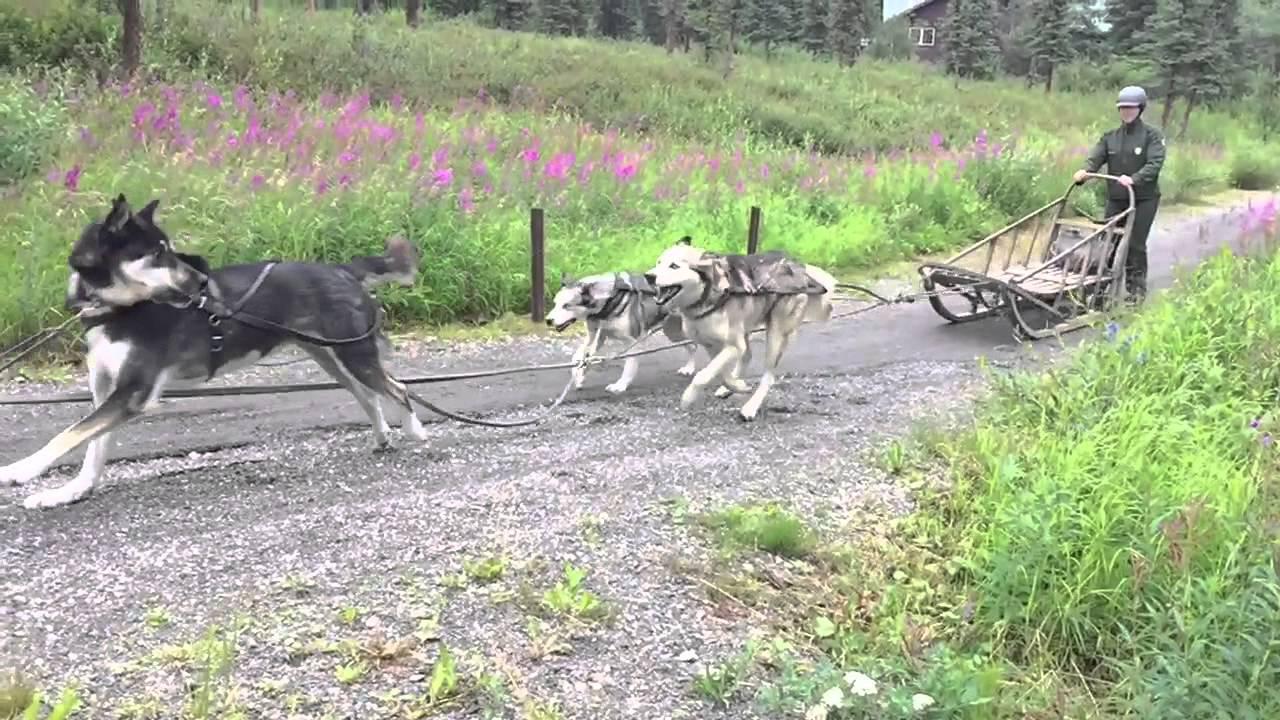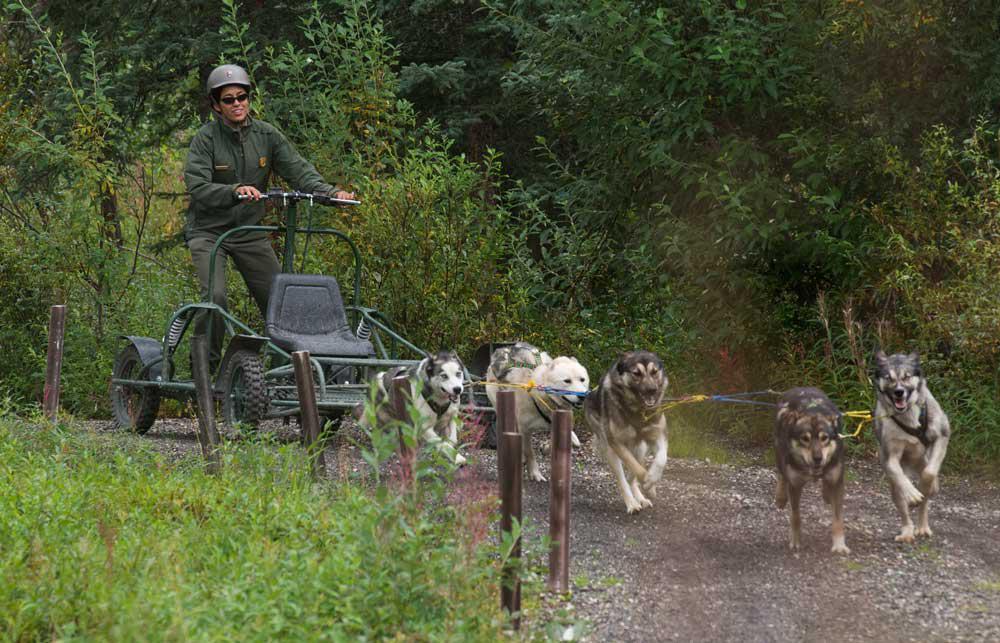The first image is the image on the left, the second image is the image on the right. Analyze the images presented: Is the assertion "Right image shows a team of sled dogs headed straight toward the camera, and left image includes treeless mountains." valid? Answer yes or no. No. The first image is the image on the left, the second image is the image on the right. For the images displayed, is the sentence "Three people are riding a sled in one of the images." factually correct? Answer yes or no. No. 